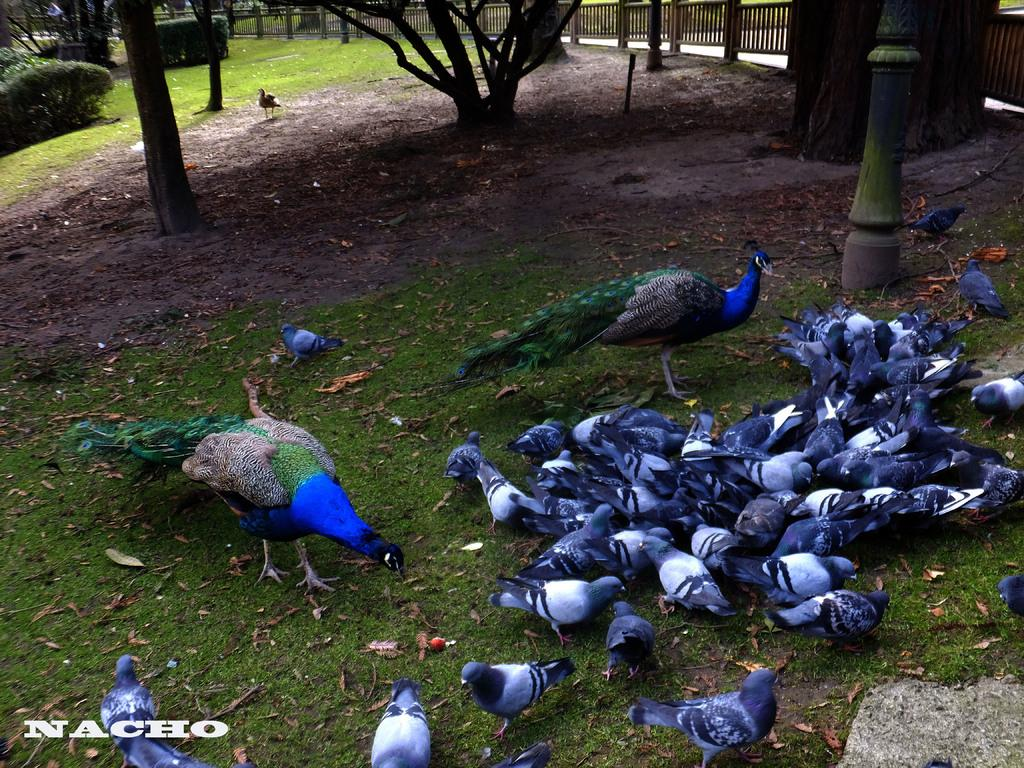Where was the image taken? The image was taken in a zoo. What animals can be seen in the foreground of the picture? There are pigeons and peacocks in the foreground of the picture. What type of vegetation is present in the foreground of the picture? There are dry leaves and grass in the foreground of the picture. What can be seen in the background of the picture? There are trees, soil, plants, a railing, and a bird in the background of the picture. How many elbows can be seen in the image? There are no elbows visible in the image. Are there any police officers present in the image? There is no mention of police officers in the image. 